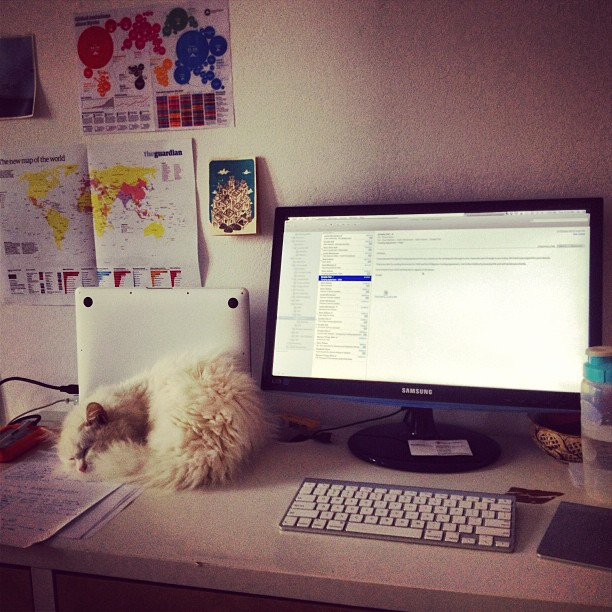<image>What gender is the person on the calendar? It is ambiguous what gender is the person on the calendar. The calendar may not be visible. What gender is the person on the calendar? I don't know the gender of the person on the calendar. It is not possible to determine from the given information. 